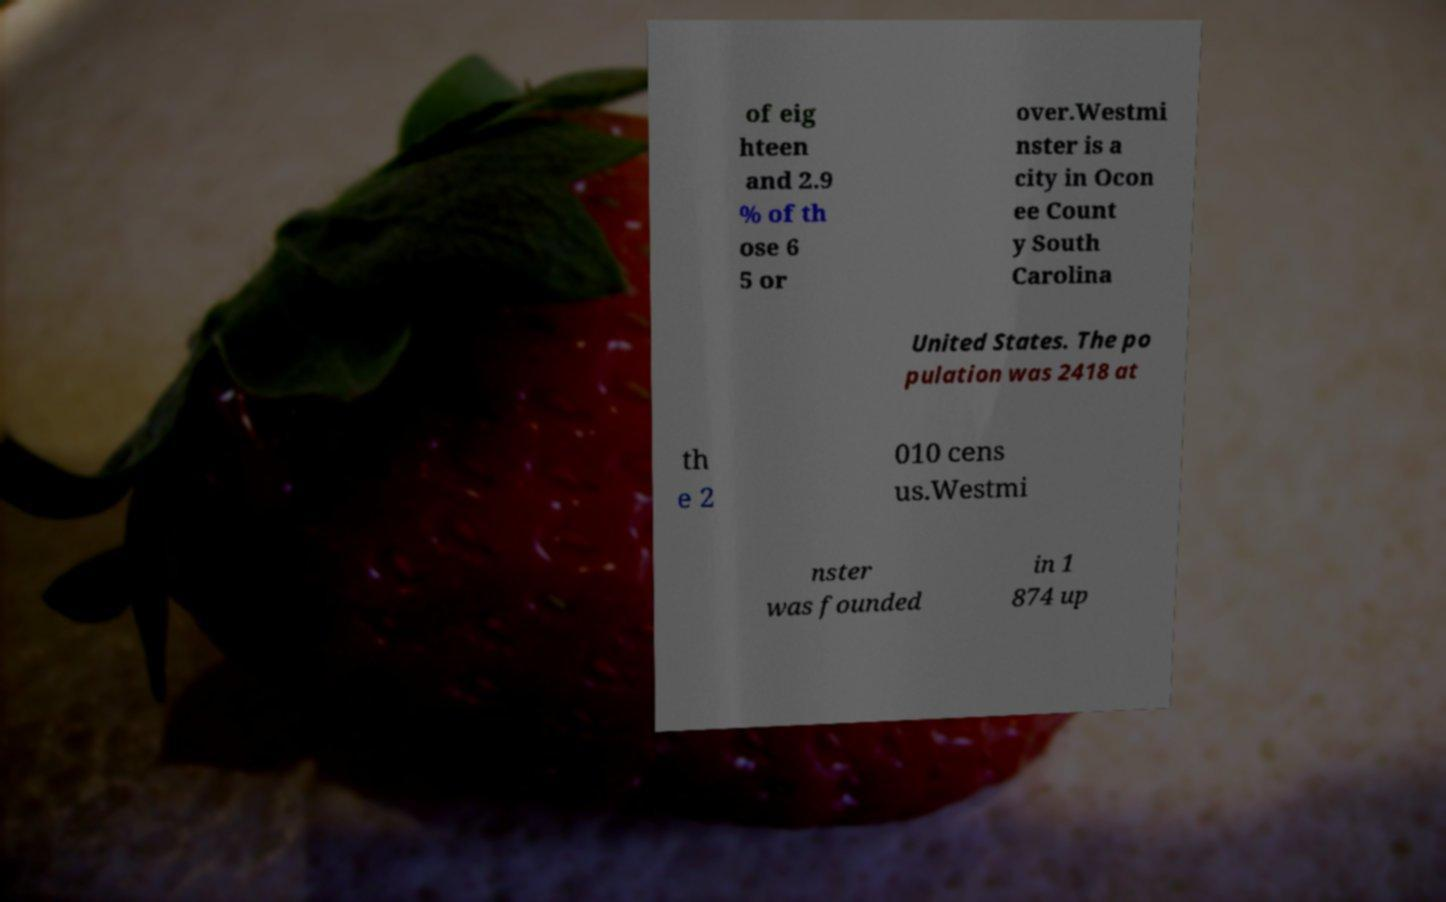Please read and relay the text visible in this image. What does it say? of eig hteen and 2.9 % of th ose 6 5 or over.Westmi nster is a city in Ocon ee Count y South Carolina United States. The po pulation was 2418 at th e 2 010 cens us.Westmi nster was founded in 1 874 up 